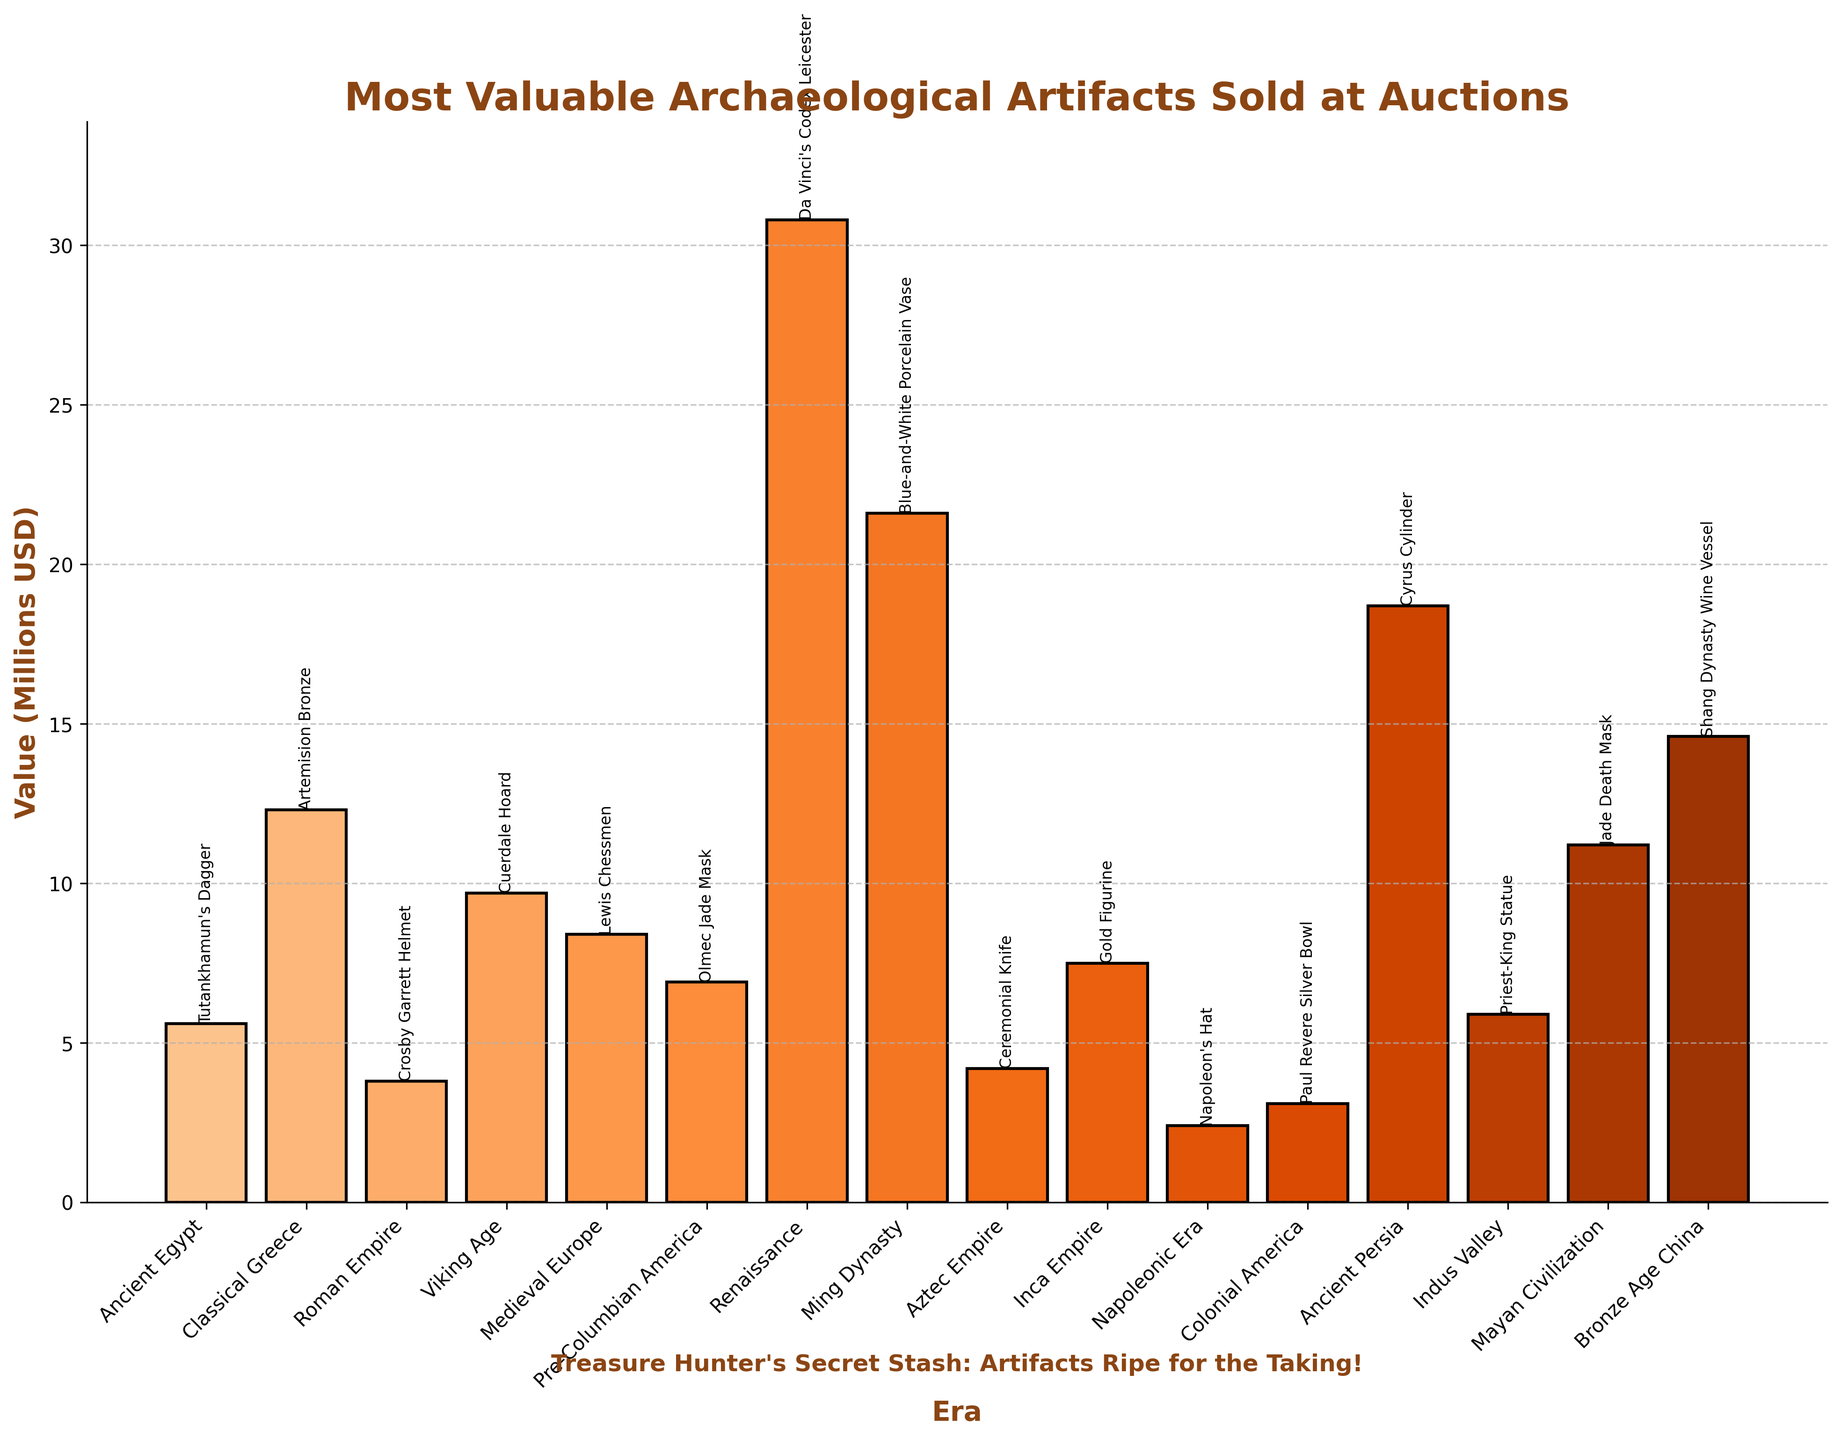What artifact from the Renaissance had the highest auction value? The bar chart indicates that the Renaissance artifact "Da Vinci's Codex Leicester" had a value of $30.8 million, which is the highest among Renaissance artifacts.
Answer: Da Vinci's Codex Leicester Which era’s artifact has the second-highest auction value? By examining the heights of the bars, the Ming Dynasty’s "Blue-and-White Porcelain Vase" stands out with a value of $21.6 million, making it the second highest.
Answer: Ming Dynasty What is the combined value of artifacts from Ancient Persia and Bronze Age China? The values for Ancient Persia's "Cyrus Cylinder" is $18.7 million and Bronze Age China's "Shang Dynasty Wine Vessel" is $14.6 million. Summing these values: $18.7 million + $14.6 million = $33.3 million.
Answer: $33.3 million How does the value of the Viking Age artifact compare to the Pre-Columbian America artifact? The Viking Age artifact "Cuerdale Hoard" is valued at $9.7 million, while the Pre-Columbian America artifact "Olmec Jade Mask" is valued at $6.9 million. The Viking Age artifact is more valuable: $9.7 million > $6.9 million.
Answer: Viking Age artifact is more valuable Which artifact from the Ancient Egypt era is displayed, and what is its auction value? The bar chart shows "Tutankhamun's Dagger" from Ancient Egypt with a value of $5.6 million.
Answer: Tutankhamun's Dagger, $5.6 million Calculate the average value of the top three most expensive artifacts. The top three artifacts are "Da Vinci's Codex Leicester" ($30.8 million), "Blue-and-White Porcelain Vase" ($21.6 million), and "Cyrus Cylinder" ($18.7 million). The average is calculated as: (30.8 + 21.6 + 18.7)/3 = 71.1 / 3 ≈ $23.7 million.
Answer: $23.7 million What is the difference in value between the highest and lowest valued artifacts? The highest value is $30.8 million for "Da Vinci's Codex Leicester" and the lowest is $2.4 million for "Napoleon's Hat". The difference is calculated as $30.8 million - $2.4 million = $28.4 million.
Answer: $28.4 million Which artifact from the Napoleonic Era is displayed, and what is its value? The chart shows "Napoleon's Hat" from the Napoleonic Era with a value of $2.4 million.
Answer: Napoleon's Hat, $2.4 million What is the total value of all artifacts listed from the chart? Summing the values for all artifacts: 5.6 + 12.3 + 3.8 + 9.7 + 8.4 + 6.9 + 30.8 + 21.6 + 4.2 + 7.5 + 2.4 + 3.1 + 18.7 + 5.9 + 11.2 + 14.6 = $166.7 million.
Answer: $166.7 million How many artifacts have a value greater than $10 million? The artifacts with values greater than $10 million are "Artemision Bronze", "Da Vinci's Codex Leicester", "Blue-and-White Porcelain Vase", "Cyrus Cylinder", "Jade Death Mask", and "Shang Dynasty Wine Vessel". There are a total of 6 artifacts.
Answer: 6 